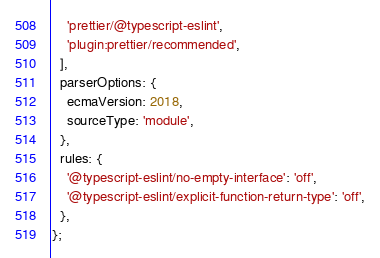<code> <loc_0><loc_0><loc_500><loc_500><_JavaScript_>    'prettier/@typescript-eslint',
    'plugin:prettier/recommended',
  ],
  parserOptions: {
    ecmaVersion: 2018,
    sourceType: 'module',
  },
  rules: {
    '@typescript-eslint/no-empty-interface': 'off',
    '@typescript-eslint/explicit-function-return-type': 'off',
  },
};
</code> 